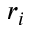<formula> <loc_0><loc_0><loc_500><loc_500>r _ { i }</formula> 